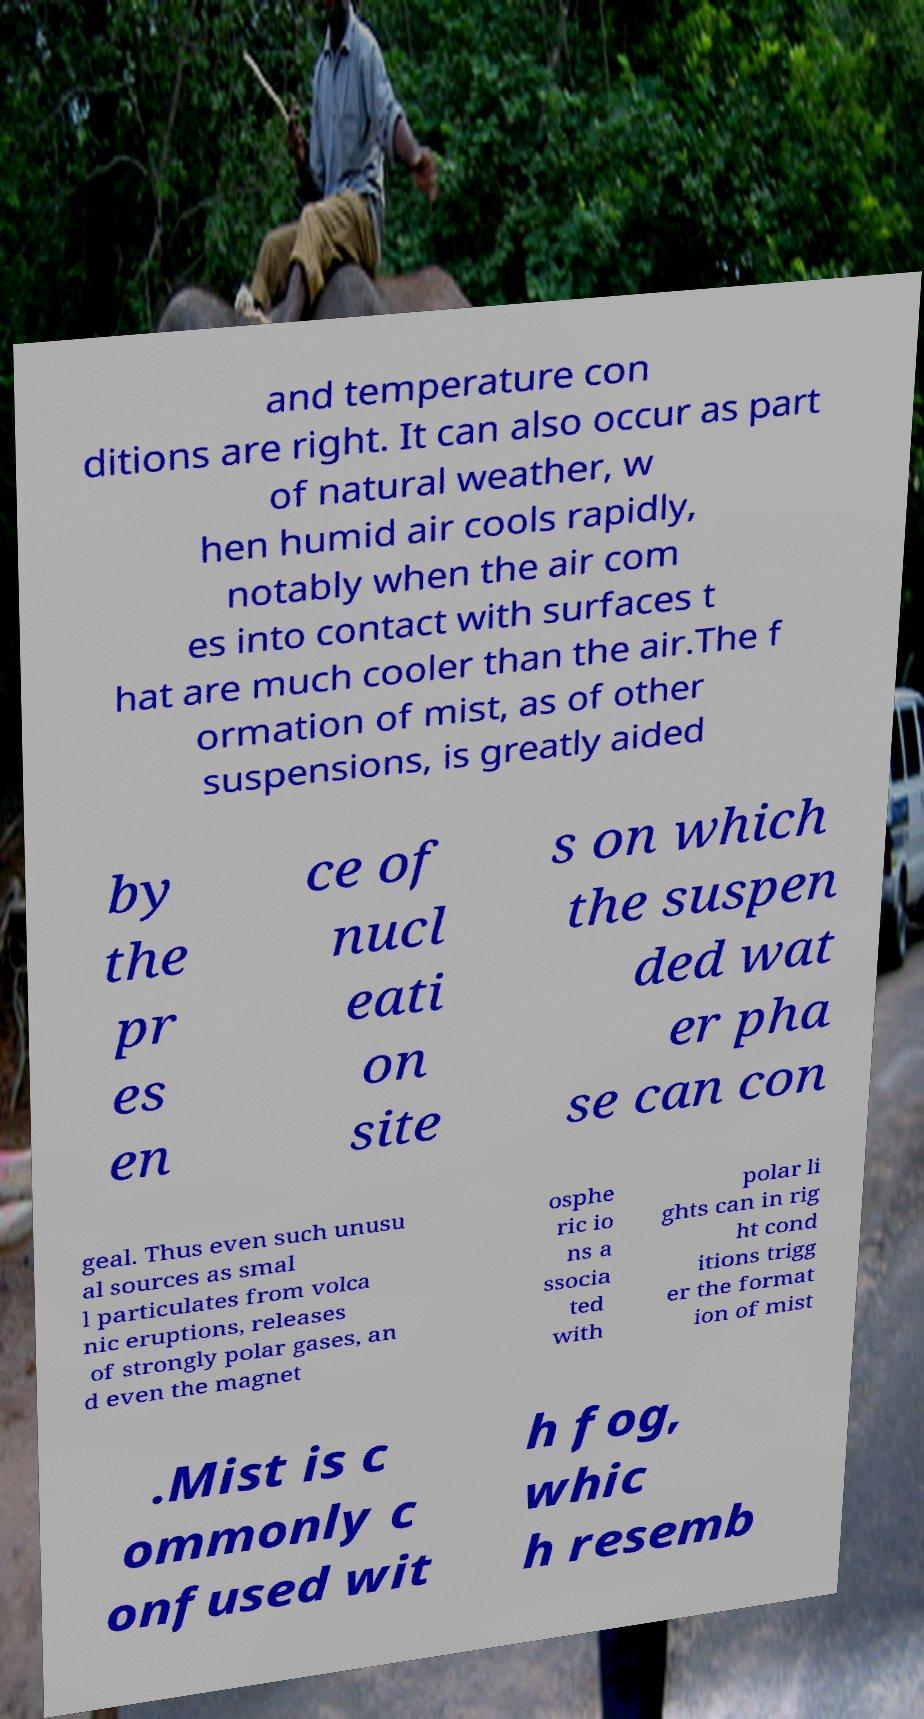What messages or text are displayed in this image? I need them in a readable, typed format. and temperature con ditions are right. It can also occur as part of natural weather, w hen humid air cools rapidly, notably when the air com es into contact with surfaces t hat are much cooler than the air.The f ormation of mist, as of other suspensions, is greatly aided by the pr es en ce of nucl eati on site s on which the suspen ded wat er pha se can con geal. Thus even such unusu al sources as smal l particulates from volca nic eruptions, releases of strongly polar gases, an d even the magnet osphe ric io ns a ssocia ted with polar li ghts can in rig ht cond itions trigg er the format ion of mist .Mist is c ommonly c onfused wit h fog, whic h resemb 